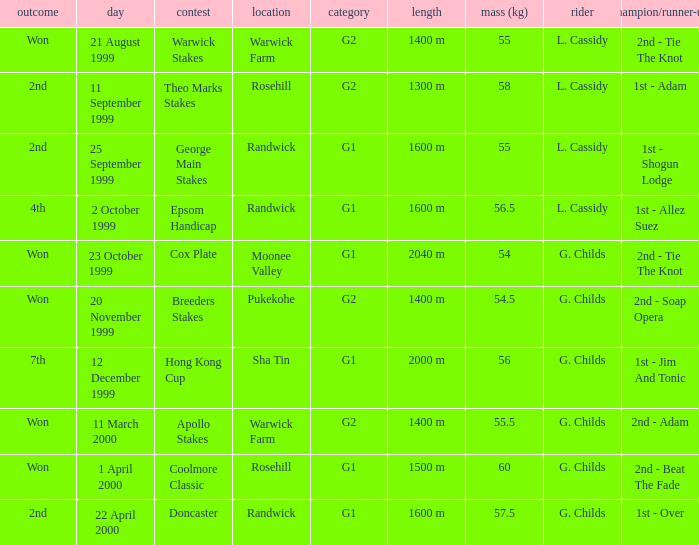List the weight for 56.5 kilograms. Epsom Handicap. 